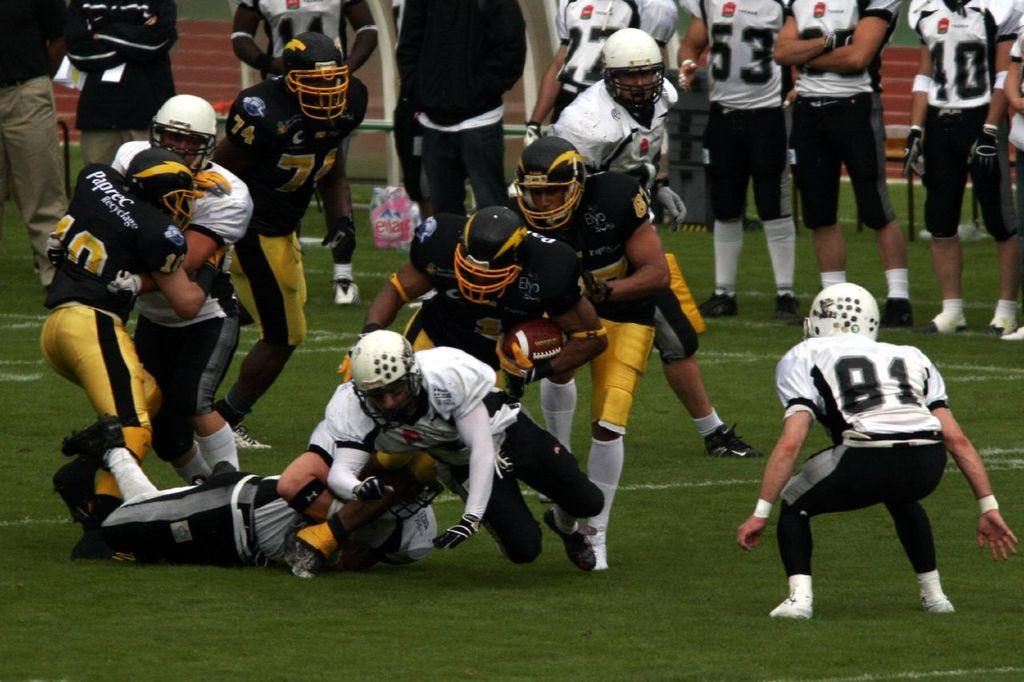What is happening on the ground in the image? There are players on the ground in the image. Are there any other people involved in the scene? Yes, there are few members standing at the back. What type of drawer can be seen in the image? There is no drawer present in the image. What school are the players from in the image? The image does not provide information about the school affiliation of the players. 